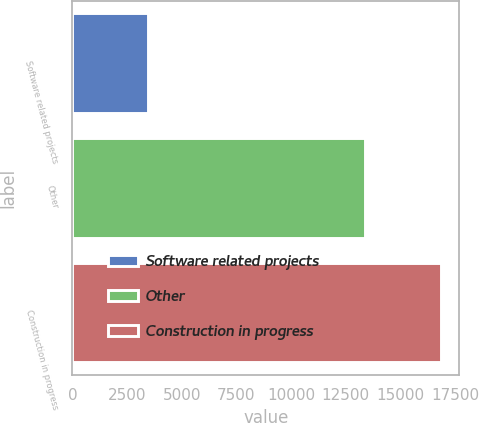Convert chart to OTSL. <chart><loc_0><loc_0><loc_500><loc_500><bar_chart><fcel>Software related projects<fcel>Other<fcel>Construction in progress<nl><fcel>3469<fcel>13375<fcel>16844<nl></chart> 